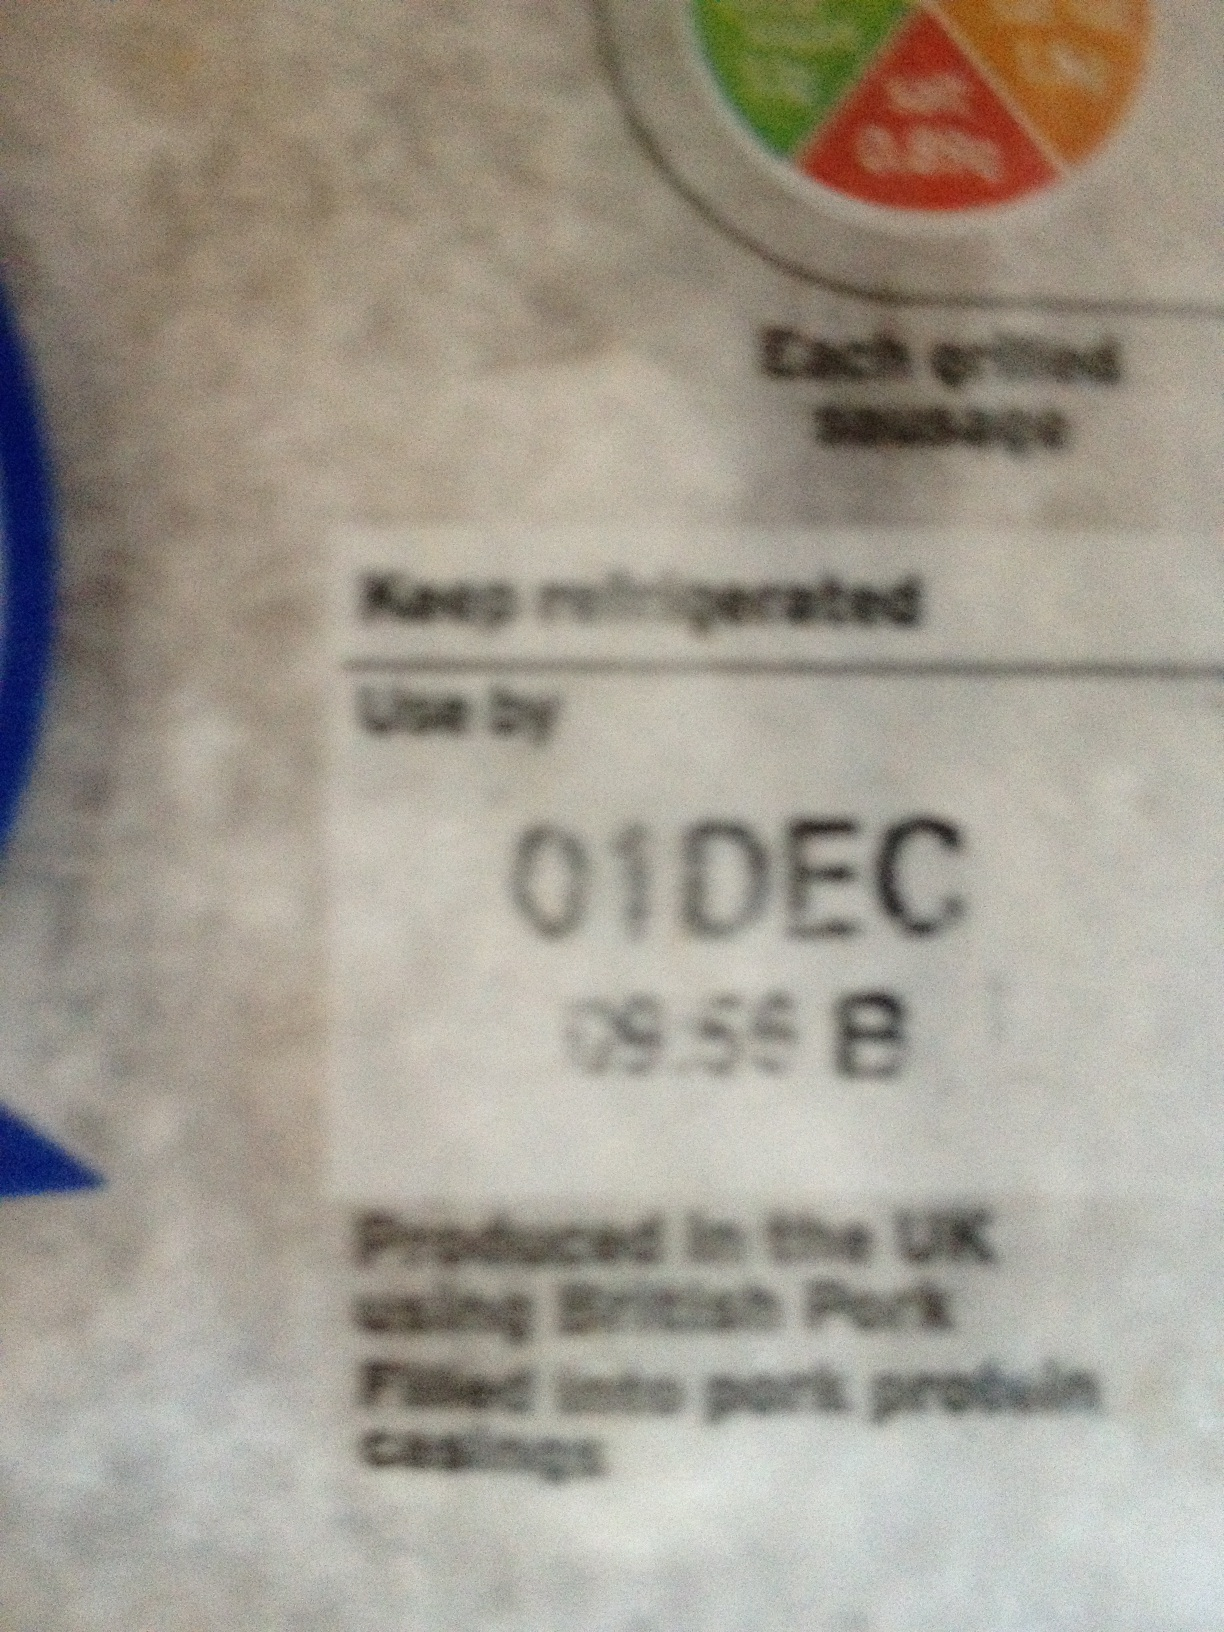Can you explain what 'Produced in the UK using British Pork' means? 'Produced in the UK using British Pork' means that the product was manufactured in the United Kingdom and uses pork sourced from British farms. This indicates a focus on local sourcing and potentially higher standards of quality and traceability. Is there any significance to the '09:55 B' timestamp? The '09:55 B' timestamp likely indicates the specific batch or production time of the product, which can be useful for tracking and quality control purposes. It helps the manufacturer trace back the production details if any issues arise. 